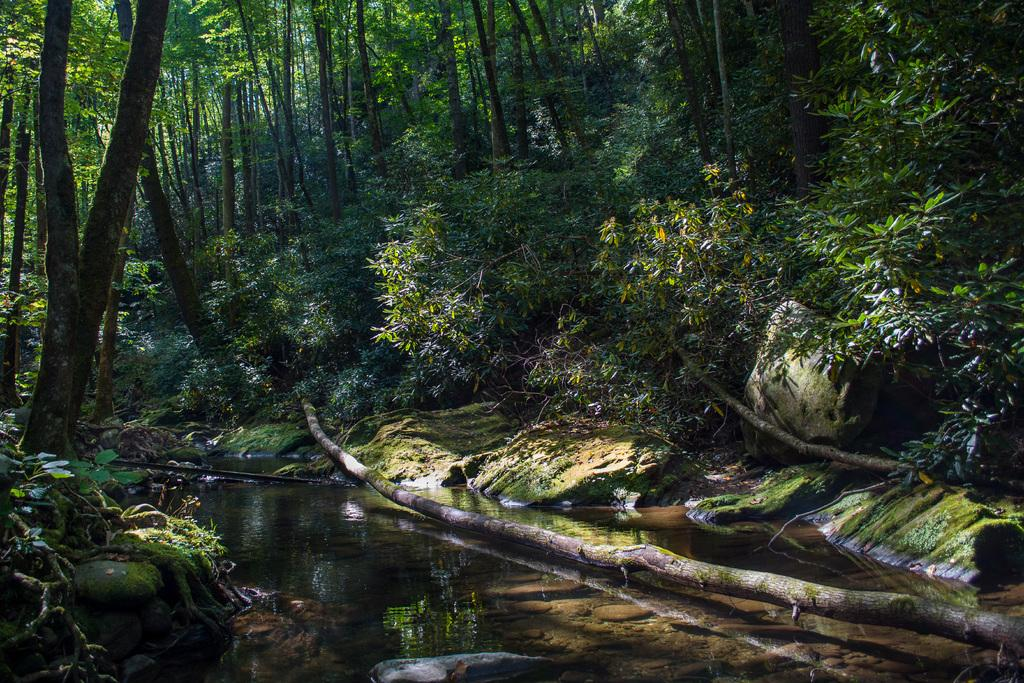What type of natural elements can be seen in the image? There are trees, logs, and rocks visible in the image. What is the primary feature at the bottom of the image? There is water visible at the bottom of the image. Can you see any plastic items in the image? There is no plastic visible in the image. Are there any animals from a zoo present in the image? There are no animals or references to a zoo in the image. 